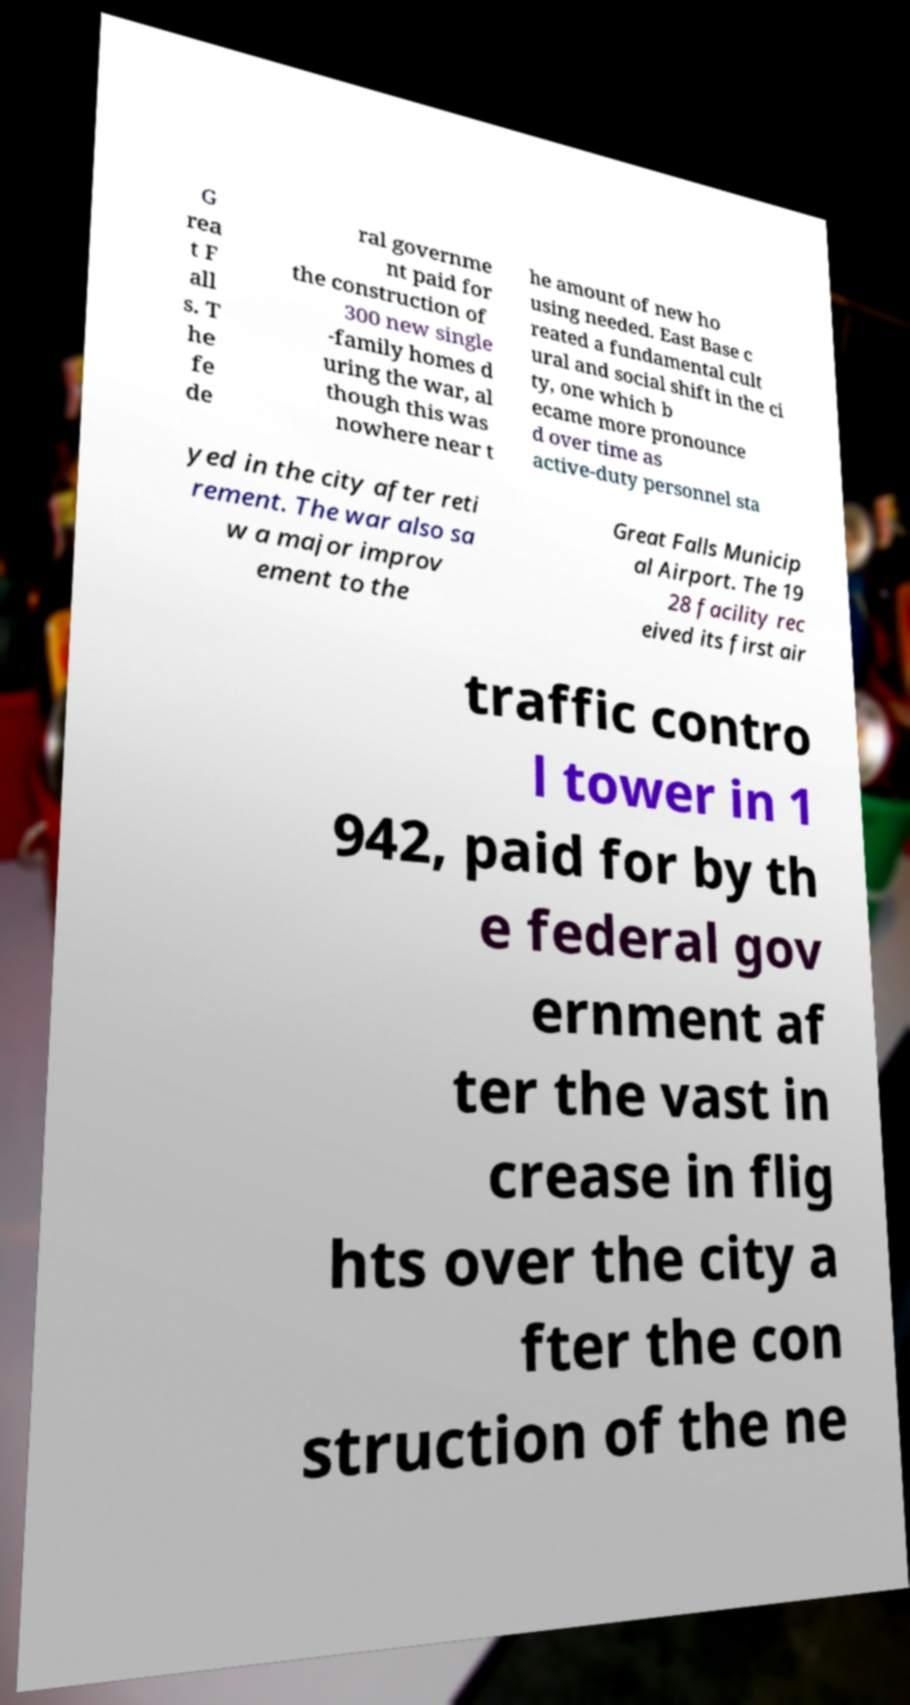Can you accurately transcribe the text from the provided image for me? G rea t F all s. T he fe de ral governme nt paid for the construction of 300 new single -family homes d uring the war, al though this was nowhere near t he amount of new ho using needed. East Base c reated a fundamental cult ural and social shift in the ci ty, one which b ecame more pronounce d over time as active-duty personnel sta yed in the city after reti rement. The war also sa w a major improv ement to the Great Falls Municip al Airport. The 19 28 facility rec eived its first air traffic contro l tower in 1 942, paid for by th e federal gov ernment af ter the vast in crease in flig hts over the city a fter the con struction of the ne 